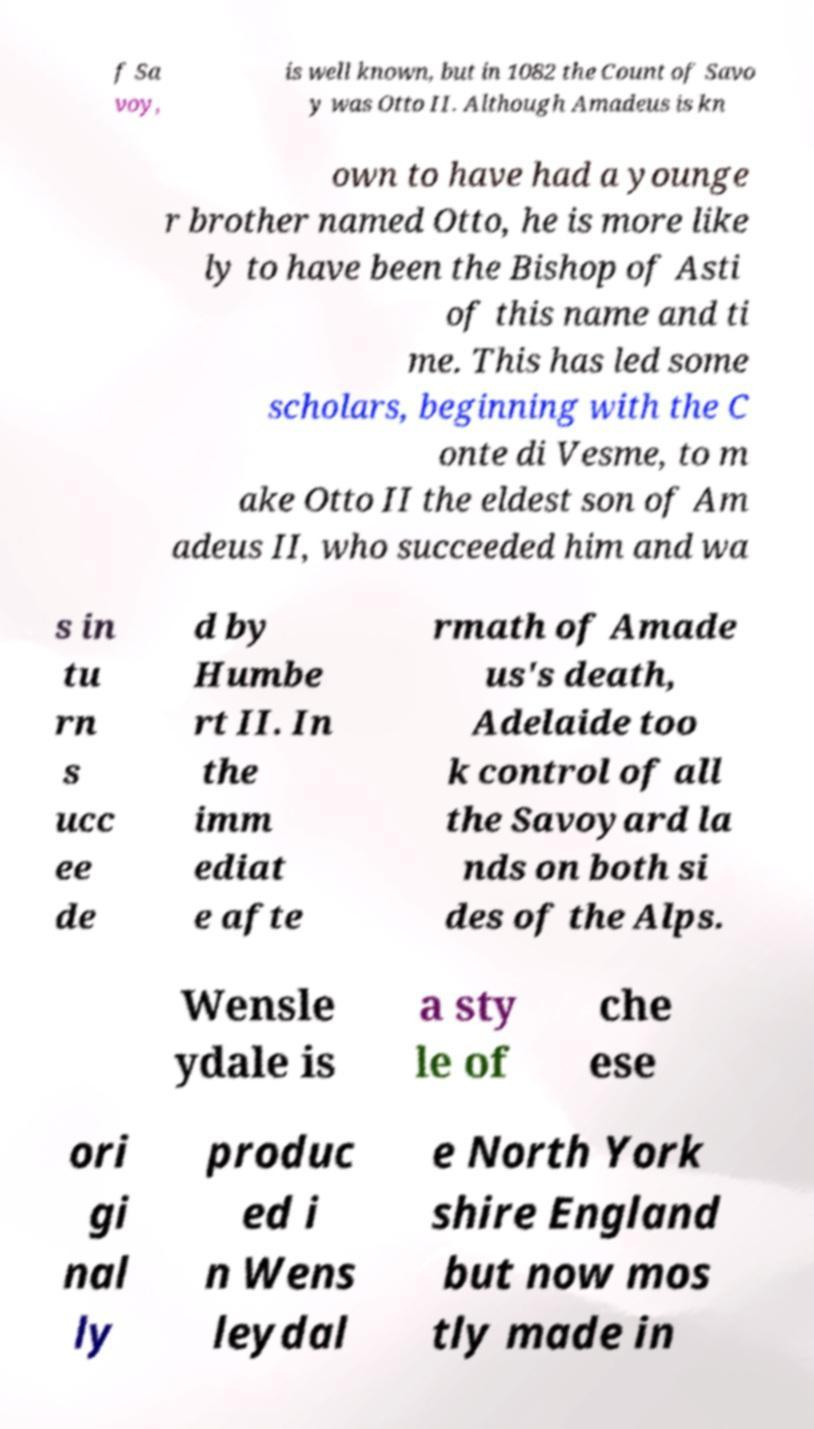Could you extract and type out the text from this image? f Sa voy, is well known, but in 1082 the Count of Savo y was Otto II. Although Amadeus is kn own to have had a younge r brother named Otto, he is more like ly to have been the Bishop of Asti of this name and ti me. This has led some scholars, beginning with the C onte di Vesme, to m ake Otto II the eldest son of Am adeus II, who succeeded him and wa s in tu rn s ucc ee de d by Humbe rt II. In the imm ediat e afte rmath of Amade us's death, Adelaide too k control of all the Savoyard la nds on both si des of the Alps. Wensle ydale is a sty le of che ese ori gi nal ly produc ed i n Wens leydal e North York shire England but now mos tly made in 